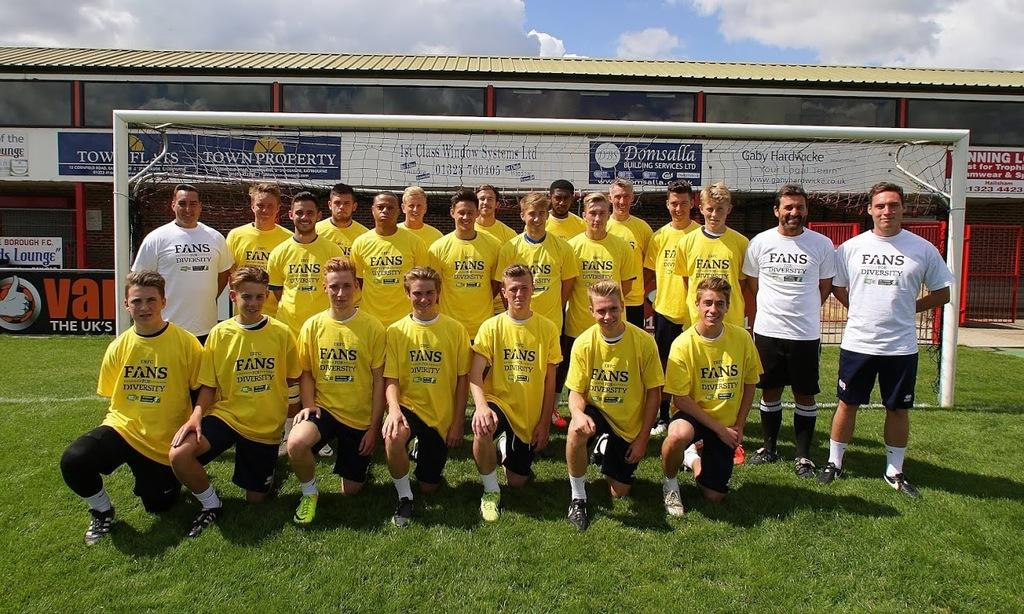What are the players on the ground in the image doing? The players on the ground in the image are likely playing a sport, as there is a net visible. What separates the two sides of the playing area? There is a net visible in the image, which separates the two sides of the playing area. What can be seen in the background of the image? In the background of the image, there is fencing and a building visible. What is visible at the top of the image? The sky is visible at the top of the image, and there are clouds in the sky. What type of approval does the shirt in the image have? There is no shirt present in the image, so it cannot be determined if it has any approval. How does the temper of the clouds in the image affect the players? The clouds in the image do not have a temper, as they are inanimate objects. The players' actions are not affected by the clouds. 